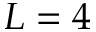<formula> <loc_0><loc_0><loc_500><loc_500>L = 4</formula> 